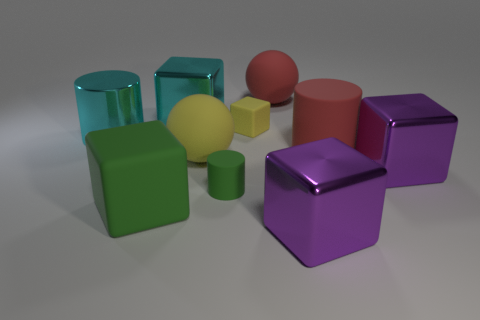Subtract all red balls. How many purple blocks are left? 2 Subtract all purple cubes. How many cubes are left? 3 Subtract 1 cylinders. How many cylinders are left? 2 Subtract all yellow cubes. How many cubes are left? 4 Subtract all cyan cubes. Subtract all gray cylinders. How many cubes are left? 4 Subtract all cylinders. How many objects are left? 7 Add 1 large yellow matte objects. How many large yellow matte objects are left? 2 Add 6 large red objects. How many large red objects exist? 8 Subtract 1 cyan cylinders. How many objects are left? 9 Subtract all big green rubber blocks. Subtract all big yellow things. How many objects are left? 8 